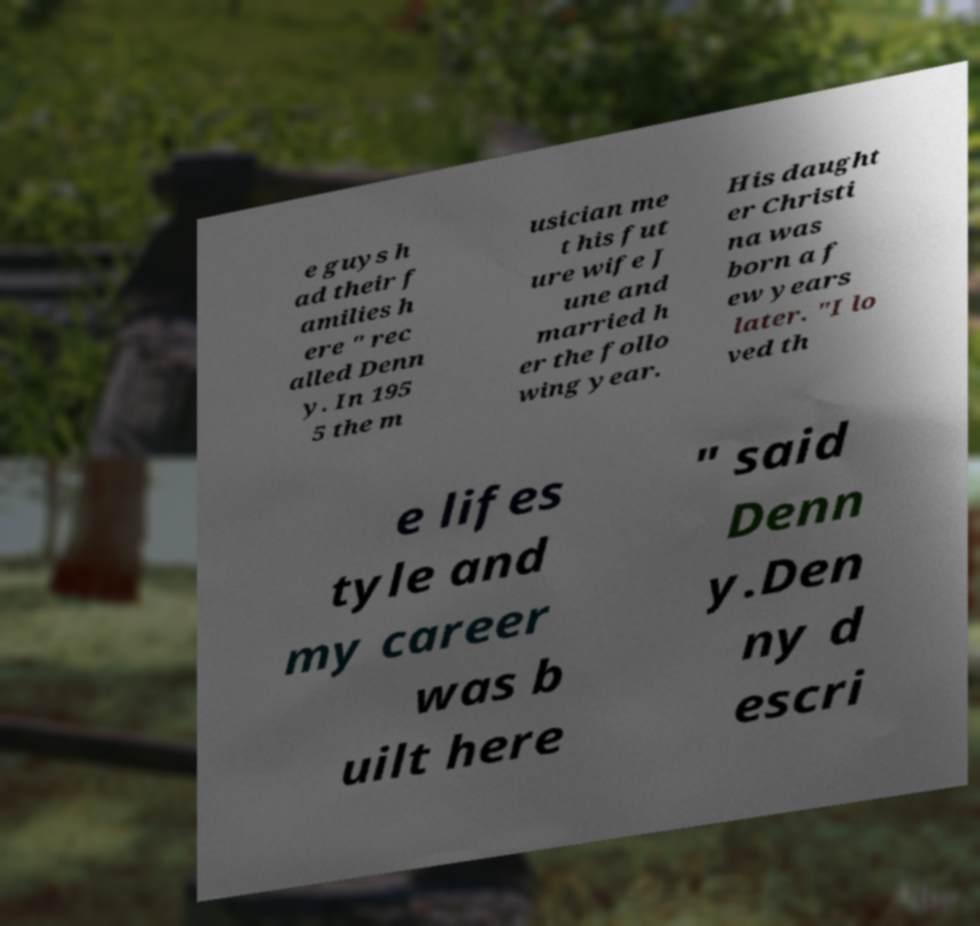What messages or text are displayed in this image? I need them in a readable, typed format. e guys h ad their f amilies h ere " rec alled Denn y. In 195 5 the m usician me t his fut ure wife J une and married h er the follo wing year. His daught er Christi na was born a f ew years later. "I lo ved th e lifes tyle and my career was b uilt here " said Denn y.Den ny d escri 